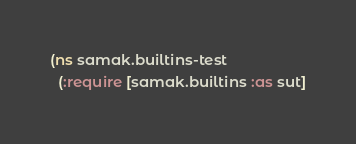<code> <loc_0><loc_0><loc_500><loc_500><_Clojure_>(ns samak.builtins-test
  (:require [samak.builtins :as sut]</code> 